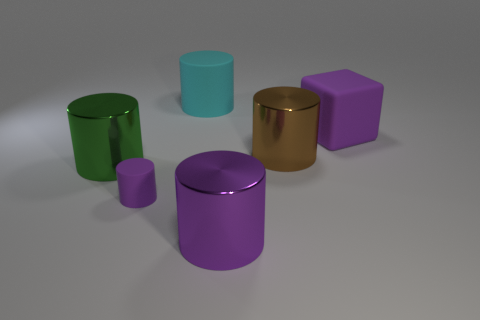Is there any other thing that is the same size as the purple matte cylinder?
Offer a terse response. No. How big is the rubber object in front of the green object?
Your response must be concise. Small. Are there any big matte objects that have the same color as the small cylinder?
Keep it short and to the point. Yes. Is the color of the large cube the same as the small matte cylinder?
Your answer should be compact. Yes. There is a big metallic object that is the same color as the tiny matte cylinder; what is its shape?
Make the answer very short. Cylinder. There is a thing in front of the tiny rubber object; what number of brown metallic cylinders are behind it?
Your response must be concise. 1. How many purple cylinders have the same material as the large green thing?
Keep it short and to the point. 1. There is a small matte object; are there any green metallic things on the left side of it?
Offer a terse response. Yes. What color is the other rubber thing that is the same size as the cyan rubber thing?
Your answer should be compact. Purple. What number of things are either purple metal cylinders that are right of the cyan matte thing or big shiny objects?
Your answer should be very brief. 3. 